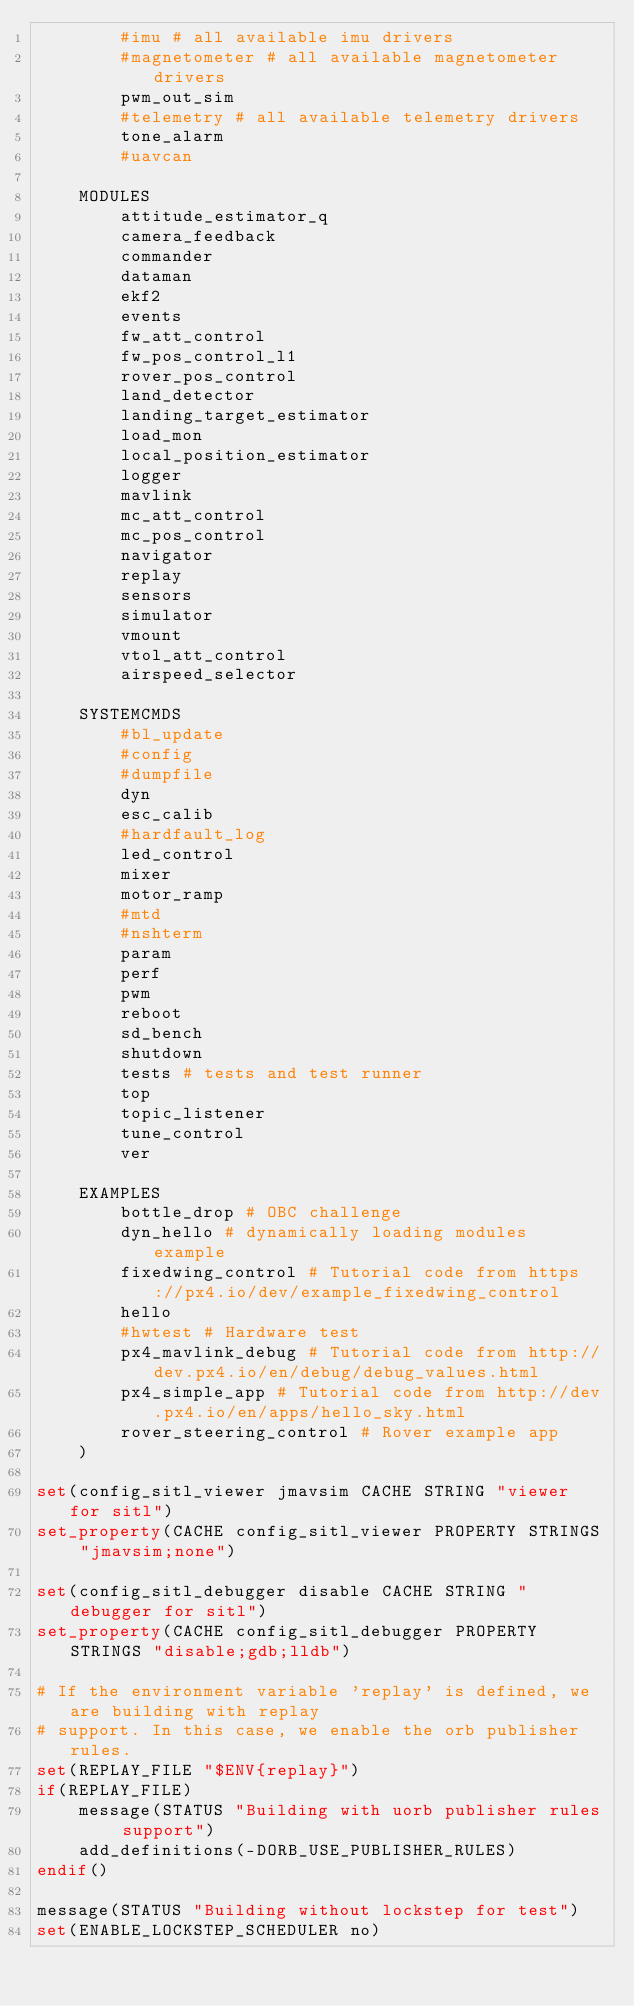Convert code to text. <code><loc_0><loc_0><loc_500><loc_500><_CMake_>		#imu # all available imu drivers
		#magnetometer # all available magnetometer drivers
		pwm_out_sim
		#telemetry # all available telemetry drivers
		tone_alarm
		#uavcan

	MODULES
		attitude_estimator_q
		camera_feedback
		commander
		dataman
		ekf2
		events
		fw_att_control
		fw_pos_control_l1
		rover_pos_control
		land_detector
		landing_target_estimator
		load_mon
		local_position_estimator
		logger
		mavlink
		mc_att_control
		mc_pos_control
		navigator
		replay
		sensors
		simulator
		vmount
		vtol_att_control
		airspeed_selector

	SYSTEMCMDS
		#bl_update
		#config
		#dumpfile
		dyn
		esc_calib
		#hardfault_log
		led_control
		mixer
		motor_ramp
		#mtd
		#nshterm
		param
		perf
		pwm
		reboot
		sd_bench
		shutdown
		tests # tests and test runner
		top
		topic_listener
		tune_control
		ver

	EXAMPLES
		bottle_drop # OBC challenge
		dyn_hello # dynamically loading modules example
		fixedwing_control # Tutorial code from https://px4.io/dev/example_fixedwing_control
		hello
		#hwtest # Hardware test
		px4_mavlink_debug # Tutorial code from http://dev.px4.io/en/debug/debug_values.html
		px4_simple_app # Tutorial code from http://dev.px4.io/en/apps/hello_sky.html
		rover_steering_control # Rover example app
	)

set(config_sitl_viewer jmavsim CACHE STRING "viewer for sitl")
set_property(CACHE config_sitl_viewer PROPERTY STRINGS "jmavsim;none")

set(config_sitl_debugger disable CACHE STRING "debugger for sitl")
set_property(CACHE config_sitl_debugger PROPERTY STRINGS "disable;gdb;lldb")

# If the environment variable 'replay' is defined, we are building with replay
# support. In this case, we enable the orb publisher rules.
set(REPLAY_FILE "$ENV{replay}")
if(REPLAY_FILE)
	message(STATUS "Building with uorb publisher rules support")
	add_definitions(-DORB_USE_PUBLISHER_RULES)
endif()

message(STATUS "Building without lockstep for test")
set(ENABLE_LOCKSTEP_SCHEDULER no)
</code> 